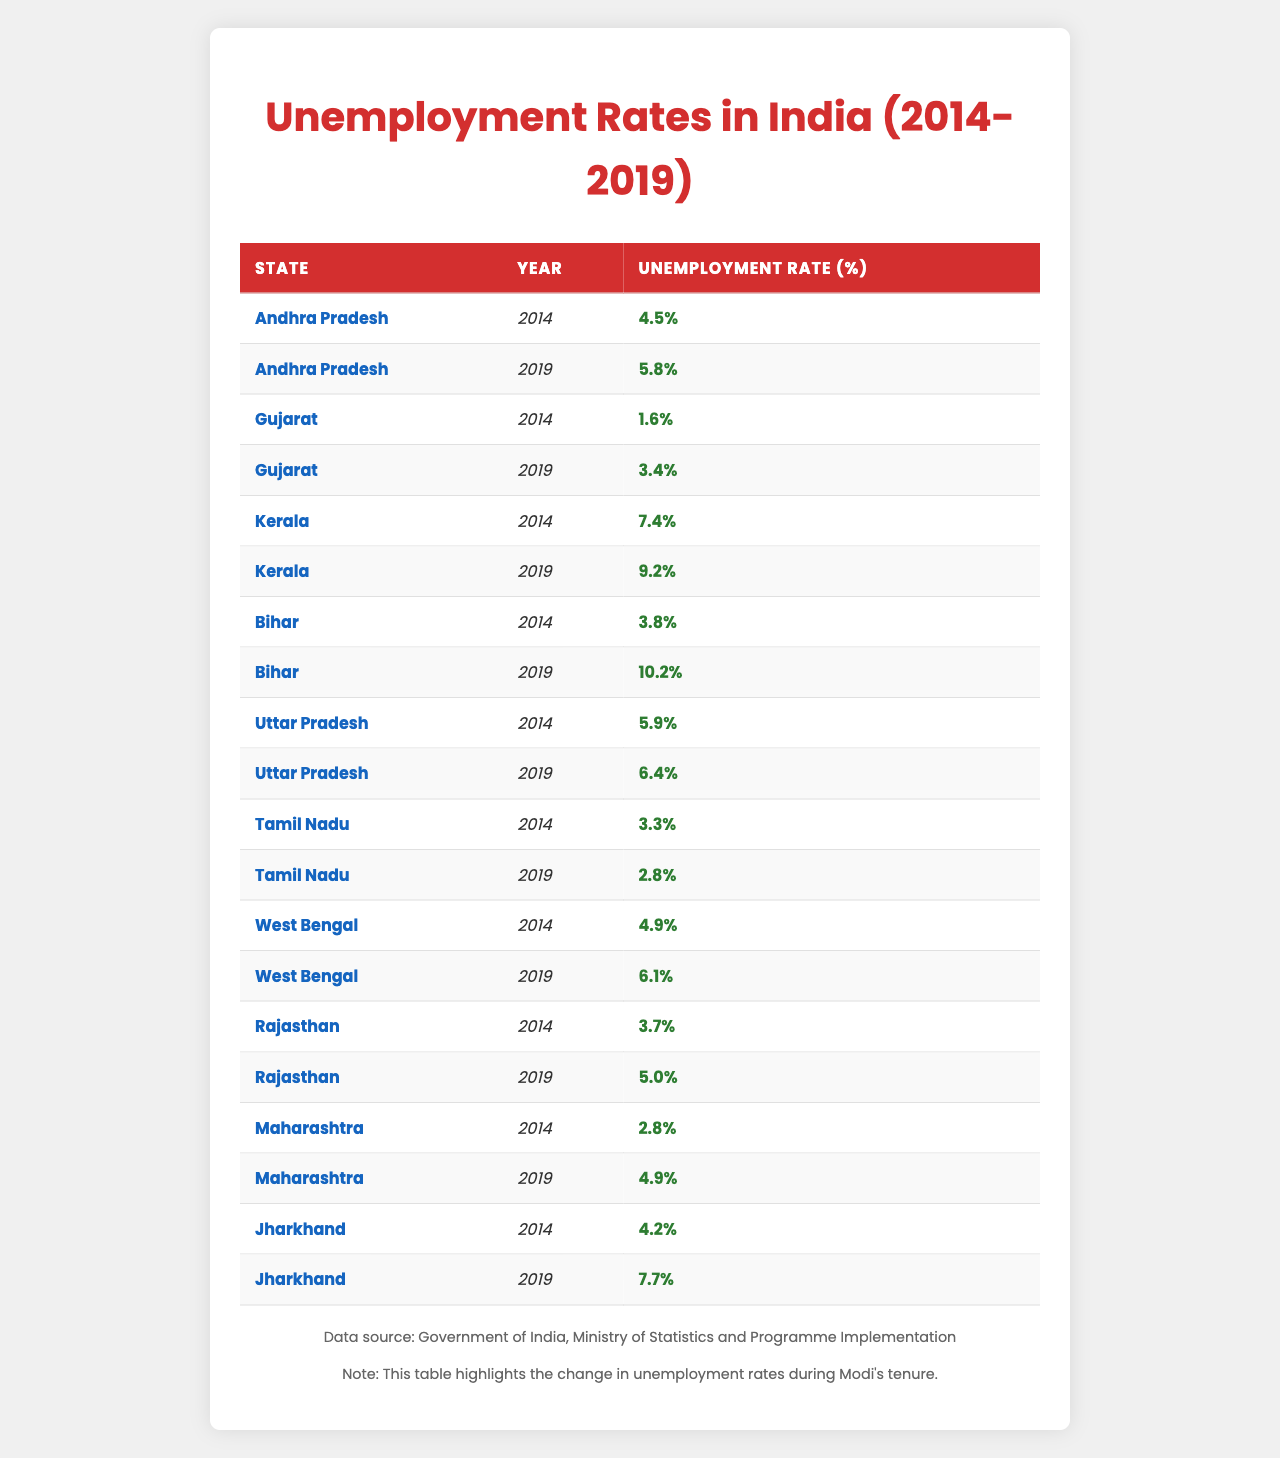What was the unemployment rate in Andhra Pradesh in 2014? According to the table, the unemployment rate in Andhra Pradesh in 2014 is specified as 4.5%.
Answer: 4.5% Which state had the highest unemployment rate in 2019? By looking at the 2019 data in the table, Kerala had the highest unemployment rate at 9.2%.
Answer: Kerala What is the change in unemployment rate for Gujarat from 2014 to 2019? In 2014, Gujarat's unemployment rate was 1.6% and in 2019 it rose to 3.4%. The change is calculated by subtracting 1.6% from 3.4%, resulting in an increase of 1.8%.
Answer: 1.8% Did Tamil Nadu experience an increase in unemployment from 2014 to 2019? The unemployment rate in Tamil Nadu was 3.3% in 2014 and decreased to 2.8% in 2019, indicating a decrease, not an increase.
Answer: No What is the average unemployment rate across all states for the year 2014? The unemployment rates for the states in 2014 are as follows: Andhra Pradesh (4.5), Gujarat (1.6), Kerala (7.4), Bihar (3.8), Uttar Pradesh (5.9), Tamil Nadu (3.3), West Bengal (4.9), Rajasthan (3.7), Maharashtra (2.8), and Jharkhand (4.2). Summing these rates gives a total of 38.1%. There are 10 states, so the average is 38.1% / 10 = 3.81%.
Answer: 3.81% Which states had a decrease in unemployment rate from 2014 to 2019? Comparing the rates from both years, Tamil Nadu (from 3.3% to 2.8%) and Gujarat (from 1.6% to 3.4%) show a decrease; others like Bihar (3.8% to 10.2%) and Kerala (7.4% to 9.2%) faced increases, which confirms multiple states had reductions in unemployment rates during this period.
Answer: Tamil Nadu What was the difference in unemployment rates between Bihar in 2019 and Rajasthan in 2019? Bihar's unemployment rate in 2019 was 10.2% and Rajasthan's was 5.0%. The difference is calculated by subtracting 5.0% from 10.2%, resulting in a difference of 5.2%.
Answer: 5.2% In 2019, which state had a lower unemployment rate, Maharashtra or Jharkhand? In 2019, Maharashtra had an unemployment rate of 4.9% compared to Jharkhand's 7.7%. Therefore, Maharashtra had a lower unemployment rate.
Answer: Maharashtra What was the increase in unemployment from 2014 to 2019 for Kerala? The unemployment rate for Kerala rose from 7.4% in 2014 to 9.2% in 2019. The increase is calculated by subtracting 7.4% from 9.2%, resulting in an increase of 1.8%.
Answer: 1.8% Is the unemployment rate in Uttar Pradesh higher than that of Tamil Nadu in 2019? Uttar Pradesh's unemployment rate in 2019 was 6.4% while Tamil Nadu's was 2.8%. This indicates that Uttar Pradesh's rate is indeed higher than that of Tamil Nadu.
Answer: Yes What was the average unemployment rate across all states in 2019? The unemployment rates for 2019 across the states are: Andhra Pradesh (5.8), Gujarat (3.4), Kerala (9.2), Bihar (10.2), Uttar Pradesh (6.4), Tamil Nadu (2.8), West Bengal (6.1), Rajasthan (5.0), Maharashtra (4.9), and Jharkhand (7.7). Summing these gives 56.4%, and dividing by 10 states gives an average of 5.64%.
Answer: 5.64% 